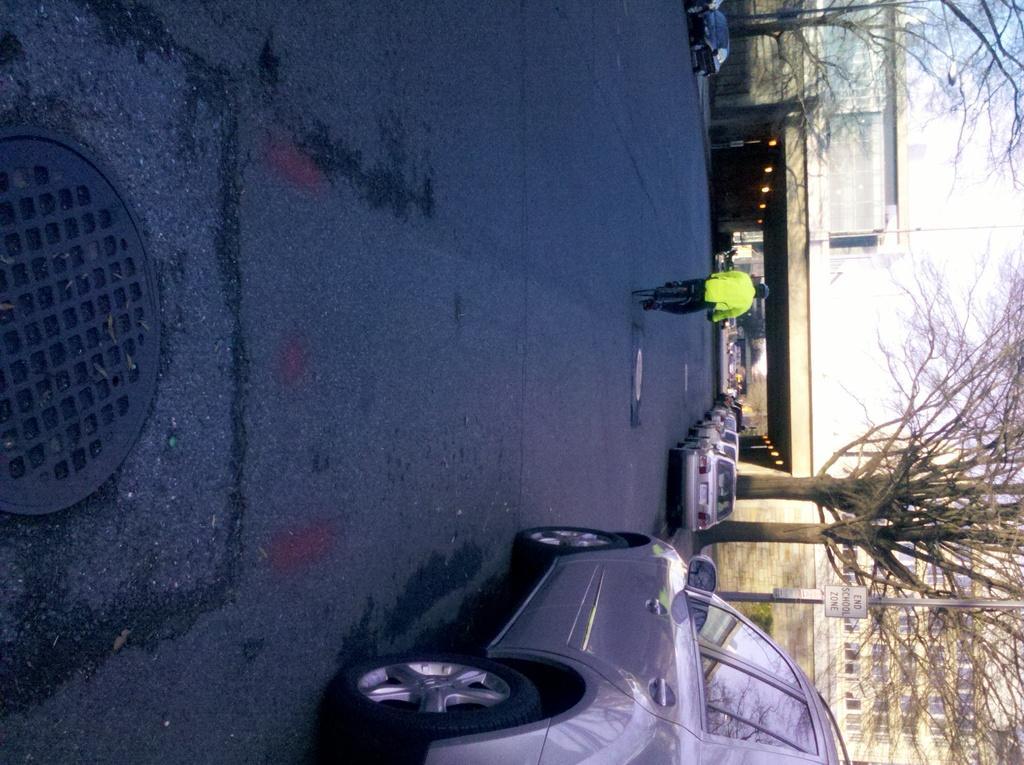Please provide a concise description of this image. In the center of the image we can see a few vehicles on the road. And we can see one person is riding a cycle. On the left side of the image, we can see one black color object. On the right side of the image, we can see the sky, clouds, buildings, trees, lights, one bridge, one pole, one sign board, few vehicles and a few other objects. 